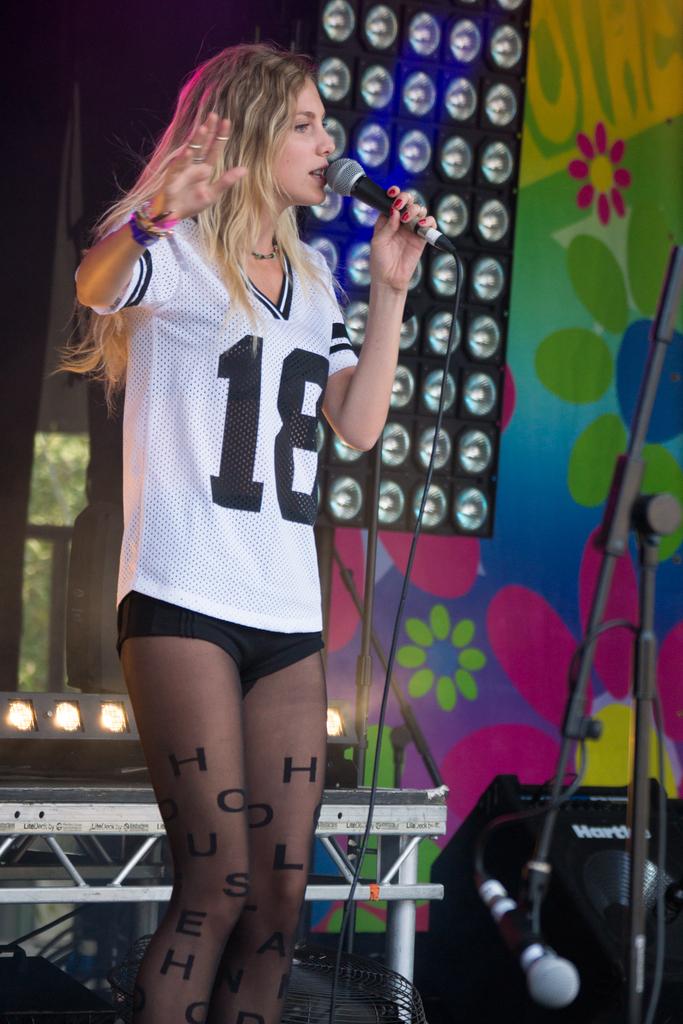What number is on her shirt?
Offer a very short reply. 18. 